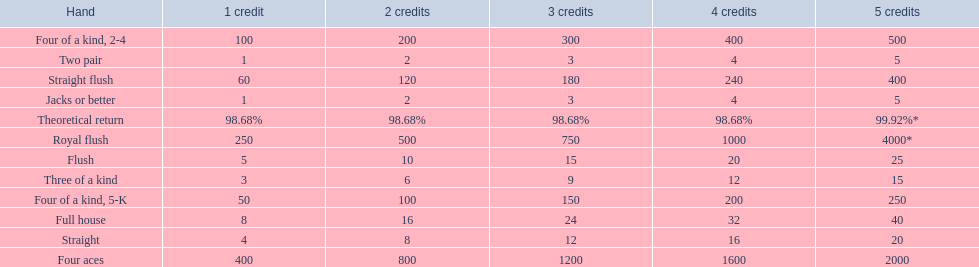Which hand is the third best hand in the card game super aces? Four aces. Which hand is the second best hand? Straight flush. Which hand had is the best hand? Royal flush. 